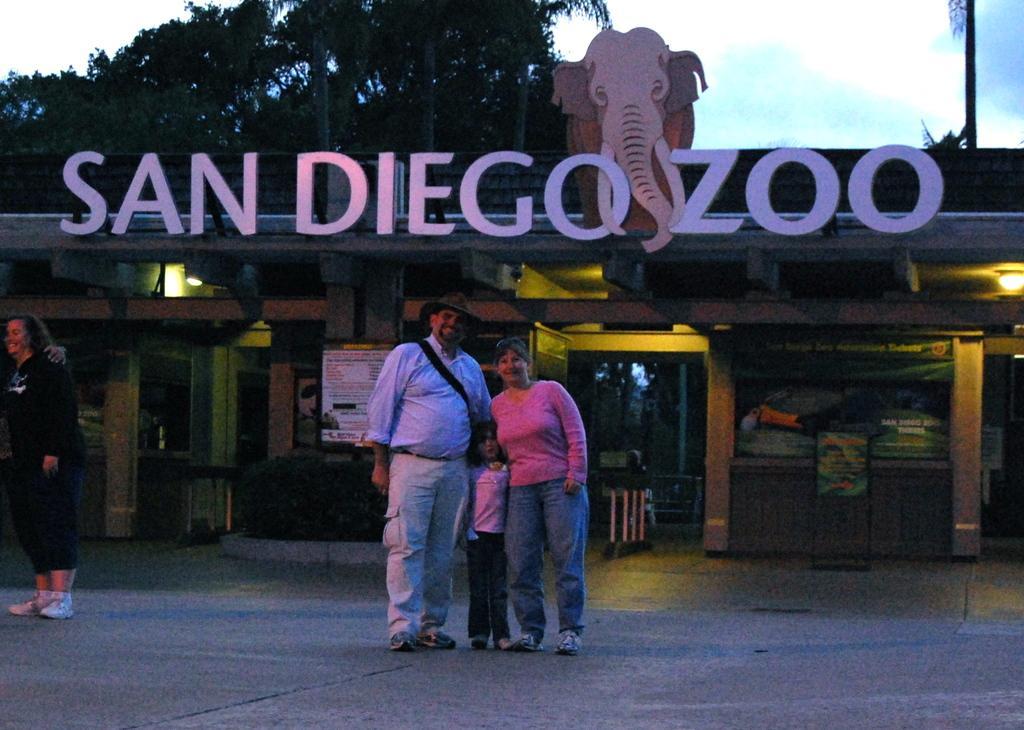Please provide a concise description of this image. We can see a man,woman and a kid are standing on the road in the middle and on the left a person is staining on the road. In the background there is a building,hoardings,lights on the ceiling,poles,wall and we can see trees and clouds in the sky. 